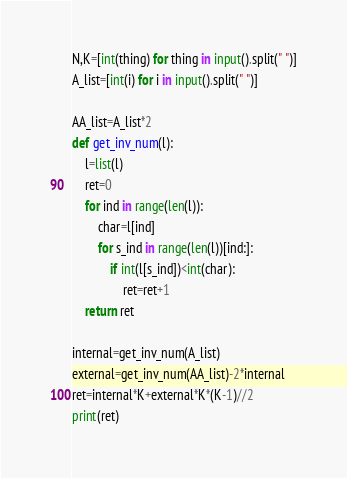Convert code to text. <code><loc_0><loc_0><loc_500><loc_500><_Python_>N,K=[int(thing) for thing in input().split(" ")]
A_list=[int(i) for i in input().split(" ")]

AA_list=A_list*2
def get_inv_num(l):
    l=list(l)
    ret=0
    for ind in range(len(l)):
        char=l[ind]
        for s_ind in range(len(l))[ind:]:
            if int(l[s_ind])<int(char):
                ret=ret+1
    return ret

internal=get_inv_num(A_list)
external=get_inv_num(AA_list)-2*internal
ret=internal*K+external*K*(K-1)//2
print(ret)</code> 